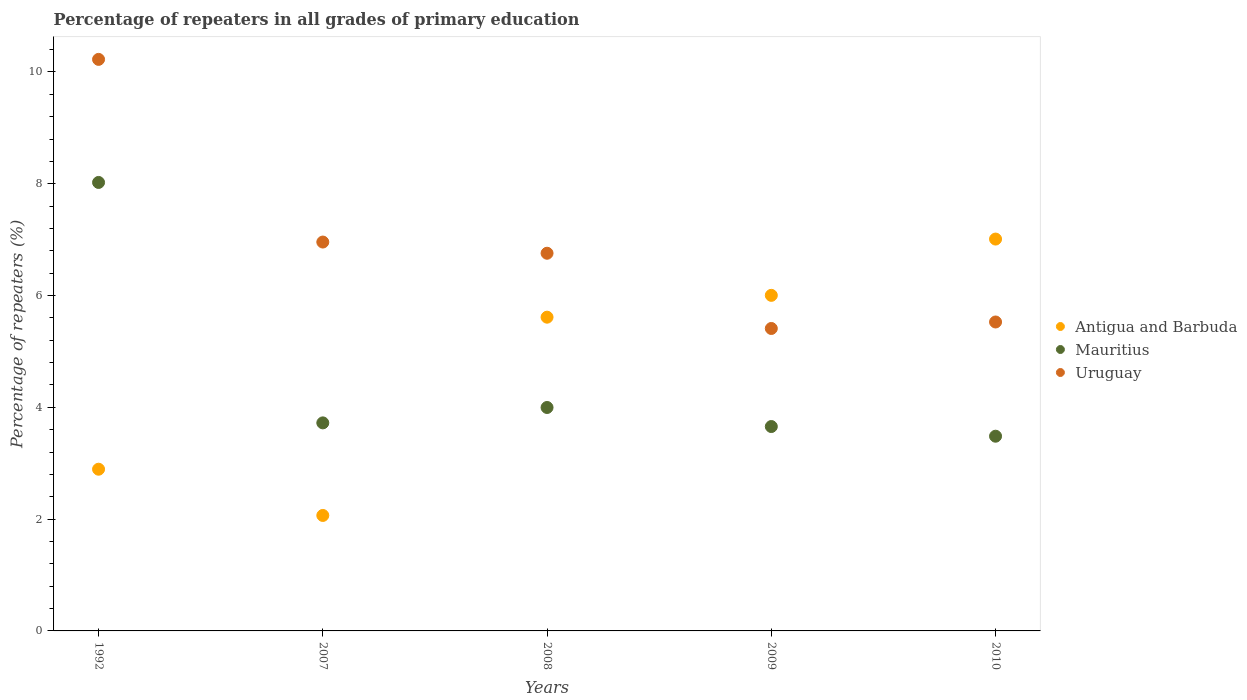How many different coloured dotlines are there?
Give a very brief answer. 3. Is the number of dotlines equal to the number of legend labels?
Ensure brevity in your answer.  Yes. What is the percentage of repeaters in Mauritius in 2007?
Make the answer very short. 3.72. Across all years, what is the maximum percentage of repeaters in Uruguay?
Your response must be concise. 10.23. Across all years, what is the minimum percentage of repeaters in Antigua and Barbuda?
Offer a very short reply. 2.07. What is the total percentage of repeaters in Mauritius in the graph?
Your response must be concise. 22.88. What is the difference between the percentage of repeaters in Uruguay in 2009 and that in 2010?
Provide a short and direct response. -0.12. What is the difference between the percentage of repeaters in Antigua and Barbuda in 2010 and the percentage of repeaters in Mauritius in 2007?
Give a very brief answer. 3.29. What is the average percentage of repeaters in Antigua and Barbuda per year?
Offer a very short reply. 4.72. In the year 2009, what is the difference between the percentage of repeaters in Uruguay and percentage of repeaters in Antigua and Barbuda?
Ensure brevity in your answer.  -0.59. What is the ratio of the percentage of repeaters in Antigua and Barbuda in 2007 to that in 2009?
Your answer should be compact. 0.34. What is the difference between the highest and the second highest percentage of repeaters in Antigua and Barbuda?
Provide a succinct answer. 1.01. What is the difference between the highest and the lowest percentage of repeaters in Uruguay?
Your answer should be compact. 4.81. In how many years, is the percentage of repeaters in Mauritius greater than the average percentage of repeaters in Mauritius taken over all years?
Your response must be concise. 1. Is it the case that in every year, the sum of the percentage of repeaters in Antigua and Barbuda and percentage of repeaters in Mauritius  is greater than the percentage of repeaters in Uruguay?
Your answer should be very brief. No. Is the percentage of repeaters in Uruguay strictly greater than the percentage of repeaters in Antigua and Barbuda over the years?
Your answer should be very brief. No. Is the percentage of repeaters in Uruguay strictly less than the percentage of repeaters in Antigua and Barbuda over the years?
Ensure brevity in your answer.  No. What is the difference between two consecutive major ticks on the Y-axis?
Make the answer very short. 2. Does the graph contain any zero values?
Make the answer very short. No. How are the legend labels stacked?
Your answer should be compact. Vertical. What is the title of the graph?
Provide a short and direct response. Percentage of repeaters in all grades of primary education. Does "Yemen, Rep." appear as one of the legend labels in the graph?
Give a very brief answer. No. What is the label or title of the X-axis?
Your answer should be very brief. Years. What is the label or title of the Y-axis?
Offer a very short reply. Percentage of repeaters (%). What is the Percentage of repeaters (%) of Antigua and Barbuda in 1992?
Provide a short and direct response. 2.89. What is the Percentage of repeaters (%) in Mauritius in 1992?
Keep it short and to the point. 8.02. What is the Percentage of repeaters (%) of Uruguay in 1992?
Give a very brief answer. 10.23. What is the Percentage of repeaters (%) in Antigua and Barbuda in 2007?
Provide a short and direct response. 2.07. What is the Percentage of repeaters (%) of Mauritius in 2007?
Offer a very short reply. 3.72. What is the Percentage of repeaters (%) in Uruguay in 2007?
Make the answer very short. 6.96. What is the Percentage of repeaters (%) in Antigua and Barbuda in 2008?
Provide a succinct answer. 5.61. What is the Percentage of repeaters (%) in Mauritius in 2008?
Your answer should be compact. 4. What is the Percentage of repeaters (%) in Uruguay in 2008?
Give a very brief answer. 6.76. What is the Percentage of repeaters (%) in Antigua and Barbuda in 2009?
Your answer should be compact. 6. What is the Percentage of repeaters (%) of Mauritius in 2009?
Ensure brevity in your answer.  3.66. What is the Percentage of repeaters (%) in Uruguay in 2009?
Your response must be concise. 5.41. What is the Percentage of repeaters (%) of Antigua and Barbuda in 2010?
Offer a terse response. 7.01. What is the Percentage of repeaters (%) in Mauritius in 2010?
Your answer should be very brief. 3.48. What is the Percentage of repeaters (%) of Uruguay in 2010?
Keep it short and to the point. 5.53. Across all years, what is the maximum Percentage of repeaters (%) of Antigua and Barbuda?
Offer a terse response. 7.01. Across all years, what is the maximum Percentage of repeaters (%) of Mauritius?
Ensure brevity in your answer.  8.02. Across all years, what is the maximum Percentage of repeaters (%) in Uruguay?
Provide a short and direct response. 10.23. Across all years, what is the minimum Percentage of repeaters (%) of Antigua and Barbuda?
Offer a very short reply. 2.07. Across all years, what is the minimum Percentage of repeaters (%) in Mauritius?
Your answer should be very brief. 3.48. Across all years, what is the minimum Percentage of repeaters (%) of Uruguay?
Ensure brevity in your answer.  5.41. What is the total Percentage of repeaters (%) of Antigua and Barbuda in the graph?
Ensure brevity in your answer.  23.59. What is the total Percentage of repeaters (%) in Mauritius in the graph?
Your answer should be very brief. 22.88. What is the total Percentage of repeaters (%) of Uruguay in the graph?
Provide a short and direct response. 34.88. What is the difference between the Percentage of repeaters (%) in Antigua and Barbuda in 1992 and that in 2007?
Give a very brief answer. 0.83. What is the difference between the Percentage of repeaters (%) of Mauritius in 1992 and that in 2007?
Ensure brevity in your answer.  4.3. What is the difference between the Percentage of repeaters (%) in Uruguay in 1992 and that in 2007?
Provide a succinct answer. 3.27. What is the difference between the Percentage of repeaters (%) of Antigua and Barbuda in 1992 and that in 2008?
Keep it short and to the point. -2.72. What is the difference between the Percentage of repeaters (%) in Mauritius in 1992 and that in 2008?
Make the answer very short. 4.03. What is the difference between the Percentage of repeaters (%) of Uruguay in 1992 and that in 2008?
Your answer should be very brief. 3.47. What is the difference between the Percentage of repeaters (%) in Antigua and Barbuda in 1992 and that in 2009?
Offer a terse response. -3.11. What is the difference between the Percentage of repeaters (%) of Mauritius in 1992 and that in 2009?
Provide a succinct answer. 4.37. What is the difference between the Percentage of repeaters (%) of Uruguay in 1992 and that in 2009?
Ensure brevity in your answer.  4.81. What is the difference between the Percentage of repeaters (%) of Antigua and Barbuda in 1992 and that in 2010?
Provide a succinct answer. -4.12. What is the difference between the Percentage of repeaters (%) of Mauritius in 1992 and that in 2010?
Your answer should be compact. 4.54. What is the difference between the Percentage of repeaters (%) in Uruguay in 1992 and that in 2010?
Keep it short and to the point. 4.7. What is the difference between the Percentage of repeaters (%) of Antigua and Barbuda in 2007 and that in 2008?
Give a very brief answer. -3.55. What is the difference between the Percentage of repeaters (%) in Mauritius in 2007 and that in 2008?
Ensure brevity in your answer.  -0.28. What is the difference between the Percentage of repeaters (%) in Uruguay in 2007 and that in 2008?
Provide a succinct answer. 0.2. What is the difference between the Percentage of repeaters (%) of Antigua and Barbuda in 2007 and that in 2009?
Provide a succinct answer. -3.94. What is the difference between the Percentage of repeaters (%) of Mauritius in 2007 and that in 2009?
Your answer should be very brief. 0.07. What is the difference between the Percentage of repeaters (%) in Uruguay in 2007 and that in 2009?
Offer a very short reply. 1.55. What is the difference between the Percentage of repeaters (%) in Antigua and Barbuda in 2007 and that in 2010?
Your response must be concise. -4.95. What is the difference between the Percentage of repeaters (%) in Mauritius in 2007 and that in 2010?
Provide a short and direct response. 0.24. What is the difference between the Percentage of repeaters (%) in Uruguay in 2007 and that in 2010?
Offer a terse response. 1.43. What is the difference between the Percentage of repeaters (%) of Antigua and Barbuda in 2008 and that in 2009?
Offer a terse response. -0.39. What is the difference between the Percentage of repeaters (%) of Mauritius in 2008 and that in 2009?
Offer a very short reply. 0.34. What is the difference between the Percentage of repeaters (%) of Uruguay in 2008 and that in 2009?
Give a very brief answer. 1.35. What is the difference between the Percentage of repeaters (%) in Antigua and Barbuda in 2008 and that in 2010?
Provide a short and direct response. -1.4. What is the difference between the Percentage of repeaters (%) of Mauritius in 2008 and that in 2010?
Your answer should be very brief. 0.51. What is the difference between the Percentage of repeaters (%) of Uruguay in 2008 and that in 2010?
Your answer should be compact. 1.23. What is the difference between the Percentage of repeaters (%) of Antigua and Barbuda in 2009 and that in 2010?
Your answer should be very brief. -1.01. What is the difference between the Percentage of repeaters (%) of Mauritius in 2009 and that in 2010?
Give a very brief answer. 0.17. What is the difference between the Percentage of repeaters (%) in Uruguay in 2009 and that in 2010?
Provide a short and direct response. -0.12. What is the difference between the Percentage of repeaters (%) in Antigua and Barbuda in 1992 and the Percentage of repeaters (%) in Mauritius in 2007?
Your answer should be very brief. -0.83. What is the difference between the Percentage of repeaters (%) of Antigua and Barbuda in 1992 and the Percentage of repeaters (%) of Uruguay in 2007?
Give a very brief answer. -4.06. What is the difference between the Percentage of repeaters (%) of Mauritius in 1992 and the Percentage of repeaters (%) of Uruguay in 2007?
Provide a short and direct response. 1.07. What is the difference between the Percentage of repeaters (%) in Antigua and Barbuda in 1992 and the Percentage of repeaters (%) in Mauritius in 2008?
Provide a short and direct response. -1.1. What is the difference between the Percentage of repeaters (%) of Antigua and Barbuda in 1992 and the Percentage of repeaters (%) of Uruguay in 2008?
Ensure brevity in your answer.  -3.86. What is the difference between the Percentage of repeaters (%) of Mauritius in 1992 and the Percentage of repeaters (%) of Uruguay in 2008?
Your answer should be very brief. 1.27. What is the difference between the Percentage of repeaters (%) of Antigua and Barbuda in 1992 and the Percentage of repeaters (%) of Mauritius in 2009?
Give a very brief answer. -0.76. What is the difference between the Percentage of repeaters (%) in Antigua and Barbuda in 1992 and the Percentage of repeaters (%) in Uruguay in 2009?
Your answer should be very brief. -2.52. What is the difference between the Percentage of repeaters (%) of Mauritius in 1992 and the Percentage of repeaters (%) of Uruguay in 2009?
Provide a short and direct response. 2.61. What is the difference between the Percentage of repeaters (%) of Antigua and Barbuda in 1992 and the Percentage of repeaters (%) of Mauritius in 2010?
Your answer should be compact. -0.59. What is the difference between the Percentage of repeaters (%) of Antigua and Barbuda in 1992 and the Percentage of repeaters (%) of Uruguay in 2010?
Provide a succinct answer. -2.63. What is the difference between the Percentage of repeaters (%) of Mauritius in 1992 and the Percentage of repeaters (%) of Uruguay in 2010?
Your answer should be compact. 2.5. What is the difference between the Percentage of repeaters (%) of Antigua and Barbuda in 2007 and the Percentage of repeaters (%) of Mauritius in 2008?
Offer a very short reply. -1.93. What is the difference between the Percentage of repeaters (%) in Antigua and Barbuda in 2007 and the Percentage of repeaters (%) in Uruguay in 2008?
Offer a very short reply. -4.69. What is the difference between the Percentage of repeaters (%) in Mauritius in 2007 and the Percentage of repeaters (%) in Uruguay in 2008?
Offer a very short reply. -3.04. What is the difference between the Percentage of repeaters (%) in Antigua and Barbuda in 2007 and the Percentage of repeaters (%) in Mauritius in 2009?
Your answer should be very brief. -1.59. What is the difference between the Percentage of repeaters (%) of Antigua and Barbuda in 2007 and the Percentage of repeaters (%) of Uruguay in 2009?
Offer a very short reply. -3.35. What is the difference between the Percentage of repeaters (%) in Mauritius in 2007 and the Percentage of repeaters (%) in Uruguay in 2009?
Your answer should be compact. -1.69. What is the difference between the Percentage of repeaters (%) in Antigua and Barbuda in 2007 and the Percentage of repeaters (%) in Mauritius in 2010?
Your answer should be very brief. -1.42. What is the difference between the Percentage of repeaters (%) in Antigua and Barbuda in 2007 and the Percentage of repeaters (%) in Uruguay in 2010?
Offer a very short reply. -3.46. What is the difference between the Percentage of repeaters (%) in Mauritius in 2007 and the Percentage of repeaters (%) in Uruguay in 2010?
Provide a succinct answer. -1.81. What is the difference between the Percentage of repeaters (%) of Antigua and Barbuda in 2008 and the Percentage of repeaters (%) of Mauritius in 2009?
Ensure brevity in your answer.  1.96. What is the difference between the Percentage of repeaters (%) in Antigua and Barbuda in 2008 and the Percentage of repeaters (%) in Uruguay in 2009?
Keep it short and to the point. 0.2. What is the difference between the Percentage of repeaters (%) in Mauritius in 2008 and the Percentage of repeaters (%) in Uruguay in 2009?
Make the answer very short. -1.41. What is the difference between the Percentage of repeaters (%) of Antigua and Barbuda in 2008 and the Percentage of repeaters (%) of Mauritius in 2010?
Keep it short and to the point. 2.13. What is the difference between the Percentage of repeaters (%) in Antigua and Barbuda in 2008 and the Percentage of repeaters (%) in Uruguay in 2010?
Provide a succinct answer. 0.09. What is the difference between the Percentage of repeaters (%) in Mauritius in 2008 and the Percentage of repeaters (%) in Uruguay in 2010?
Ensure brevity in your answer.  -1.53. What is the difference between the Percentage of repeaters (%) of Antigua and Barbuda in 2009 and the Percentage of repeaters (%) of Mauritius in 2010?
Make the answer very short. 2.52. What is the difference between the Percentage of repeaters (%) of Antigua and Barbuda in 2009 and the Percentage of repeaters (%) of Uruguay in 2010?
Ensure brevity in your answer.  0.48. What is the difference between the Percentage of repeaters (%) in Mauritius in 2009 and the Percentage of repeaters (%) in Uruguay in 2010?
Your answer should be compact. -1.87. What is the average Percentage of repeaters (%) in Antigua and Barbuda per year?
Give a very brief answer. 4.72. What is the average Percentage of repeaters (%) in Mauritius per year?
Your answer should be compact. 4.58. What is the average Percentage of repeaters (%) in Uruguay per year?
Your answer should be very brief. 6.98. In the year 1992, what is the difference between the Percentage of repeaters (%) of Antigua and Barbuda and Percentage of repeaters (%) of Mauritius?
Keep it short and to the point. -5.13. In the year 1992, what is the difference between the Percentage of repeaters (%) of Antigua and Barbuda and Percentage of repeaters (%) of Uruguay?
Ensure brevity in your answer.  -7.33. In the year 1992, what is the difference between the Percentage of repeaters (%) of Mauritius and Percentage of repeaters (%) of Uruguay?
Provide a succinct answer. -2.2. In the year 2007, what is the difference between the Percentage of repeaters (%) in Antigua and Barbuda and Percentage of repeaters (%) in Mauritius?
Keep it short and to the point. -1.66. In the year 2007, what is the difference between the Percentage of repeaters (%) in Antigua and Barbuda and Percentage of repeaters (%) in Uruguay?
Your answer should be compact. -4.89. In the year 2007, what is the difference between the Percentage of repeaters (%) in Mauritius and Percentage of repeaters (%) in Uruguay?
Provide a succinct answer. -3.24. In the year 2008, what is the difference between the Percentage of repeaters (%) in Antigua and Barbuda and Percentage of repeaters (%) in Mauritius?
Keep it short and to the point. 1.62. In the year 2008, what is the difference between the Percentage of repeaters (%) in Antigua and Barbuda and Percentage of repeaters (%) in Uruguay?
Offer a terse response. -1.14. In the year 2008, what is the difference between the Percentage of repeaters (%) in Mauritius and Percentage of repeaters (%) in Uruguay?
Your answer should be very brief. -2.76. In the year 2009, what is the difference between the Percentage of repeaters (%) of Antigua and Barbuda and Percentage of repeaters (%) of Mauritius?
Your answer should be very brief. 2.35. In the year 2009, what is the difference between the Percentage of repeaters (%) of Antigua and Barbuda and Percentage of repeaters (%) of Uruguay?
Your response must be concise. 0.59. In the year 2009, what is the difference between the Percentage of repeaters (%) in Mauritius and Percentage of repeaters (%) in Uruguay?
Offer a very short reply. -1.75. In the year 2010, what is the difference between the Percentage of repeaters (%) of Antigua and Barbuda and Percentage of repeaters (%) of Mauritius?
Give a very brief answer. 3.53. In the year 2010, what is the difference between the Percentage of repeaters (%) of Antigua and Barbuda and Percentage of repeaters (%) of Uruguay?
Make the answer very short. 1.48. In the year 2010, what is the difference between the Percentage of repeaters (%) of Mauritius and Percentage of repeaters (%) of Uruguay?
Your response must be concise. -2.04. What is the ratio of the Percentage of repeaters (%) in Antigua and Barbuda in 1992 to that in 2007?
Ensure brevity in your answer.  1.4. What is the ratio of the Percentage of repeaters (%) of Mauritius in 1992 to that in 2007?
Your answer should be very brief. 2.16. What is the ratio of the Percentage of repeaters (%) in Uruguay in 1992 to that in 2007?
Offer a very short reply. 1.47. What is the ratio of the Percentage of repeaters (%) in Antigua and Barbuda in 1992 to that in 2008?
Provide a short and direct response. 0.52. What is the ratio of the Percentage of repeaters (%) in Mauritius in 1992 to that in 2008?
Ensure brevity in your answer.  2.01. What is the ratio of the Percentage of repeaters (%) of Uruguay in 1992 to that in 2008?
Provide a short and direct response. 1.51. What is the ratio of the Percentage of repeaters (%) of Antigua and Barbuda in 1992 to that in 2009?
Provide a short and direct response. 0.48. What is the ratio of the Percentage of repeaters (%) of Mauritius in 1992 to that in 2009?
Your response must be concise. 2.19. What is the ratio of the Percentage of repeaters (%) in Uruguay in 1992 to that in 2009?
Make the answer very short. 1.89. What is the ratio of the Percentage of repeaters (%) of Antigua and Barbuda in 1992 to that in 2010?
Your answer should be very brief. 0.41. What is the ratio of the Percentage of repeaters (%) of Mauritius in 1992 to that in 2010?
Ensure brevity in your answer.  2.3. What is the ratio of the Percentage of repeaters (%) of Uruguay in 1992 to that in 2010?
Your response must be concise. 1.85. What is the ratio of the Percentage of repeaters (%) of Antigua and Barbuda in 2007 to that in 2008?
Your response must be concise. 0.37. What is the ratio of the Percentage of repeaters (%) in Mauritius in 2007 to that in 2008?
Make the answer very short. 0.93. What is the ratio of the Percentage of repeaters (%) of Uruguay in 2007 to that in 2008?
Provide a succinct answer. 1.03. What is the ratio of the Percentage of repeaters (%) of Antigua and Barbuda in 2007 to that in 2009?
Give a very brief answer. 0.34. What is the ratio of the Percentage of repeaters (%) of Mauritius in 2007 to that in 2009?
Offer a very short reply. 1.02. What is the ratio of the Percentage of repeaters (%) in Uruguay in 2007 to that in 2009?
Ensure brevity in your answer.  1.29. What is the ratio of the Percentage of repeaters (%) in Antigua and Barbuda in 2007 to that in 2010?
Make the answer very short. 0.29. What is the ratio of the Percentage of repeaters (%) in Mauritius in 2007 to that in 2010?
Offer a very short reply. 1.07. What is the ratio of the Percentage of repeaters (%) of Uruguay in 2007 to that in 2010?
Provide a short and direct response. 1.26. What is the ratio of the Percentage of repeaters (%) in Antigua and Barbuda in 2008 to that in 2009?
Give a very brief answer. 0.93. What is the ratio of the Percentage of repeaters (%) in Mauritius in 2008 to that in 2009?
Make the answer very short. 1.09. What is the ratio of the Percentage of repeaters (%) in Uruguay in 2008 to that in 2009?
Your answer should be compact. 1.25. What is the ratio of the Percentage of repeaters (%) in Antigua and Barbuda in 2008 to that in 2010?
Make the answer very short. 0.8. What is the ratio of the Percentage of repeaters (%) in Mauritius in 2008 to that in 2010?
Your response must be concise. 1.15. What is the ratio of the Percentage of repeaters (%) in Uruguay in 2008 to that in 2010?
Your response must be concise. 1.22. What is the ratio of the Percentage of repeaters (%) in Antigua and Barbuda in 2009 to that in 2010?
Offer a terse response. 0.86. What is the ratio of the Percentage of repeaters (%) of Mauritius in 2009 to that in 2010?
Offer a very short reply. 1.05. What is the difference between the highest and the second highest Percentage of repeaters (%) of Antigua and Barbuda?
Give a very brief answer. 1.01. What is the difference between the highest and the second highest Percentage of repeaters (%) of Mauritius?
Give a very brief answer. 4.03. What is the difference between the highest and the second highest Percentage of repeaters (%) of Uruguay?
Offer a terse response. 3.27. What is the difference between the highest and the lowest Percentage of repeaters (%) of Antigua and Barbuda?
Your answer should be compact. 4.95. What is the difference between the highest and the lowest Percentage of repeaters (%) in Mauritius?
Make the answer very short. 4.54. What is the difference between the highest and the lowest Percentage of repeaters (%) of Uruguay?
Provide a short and direct response. 4.81. 